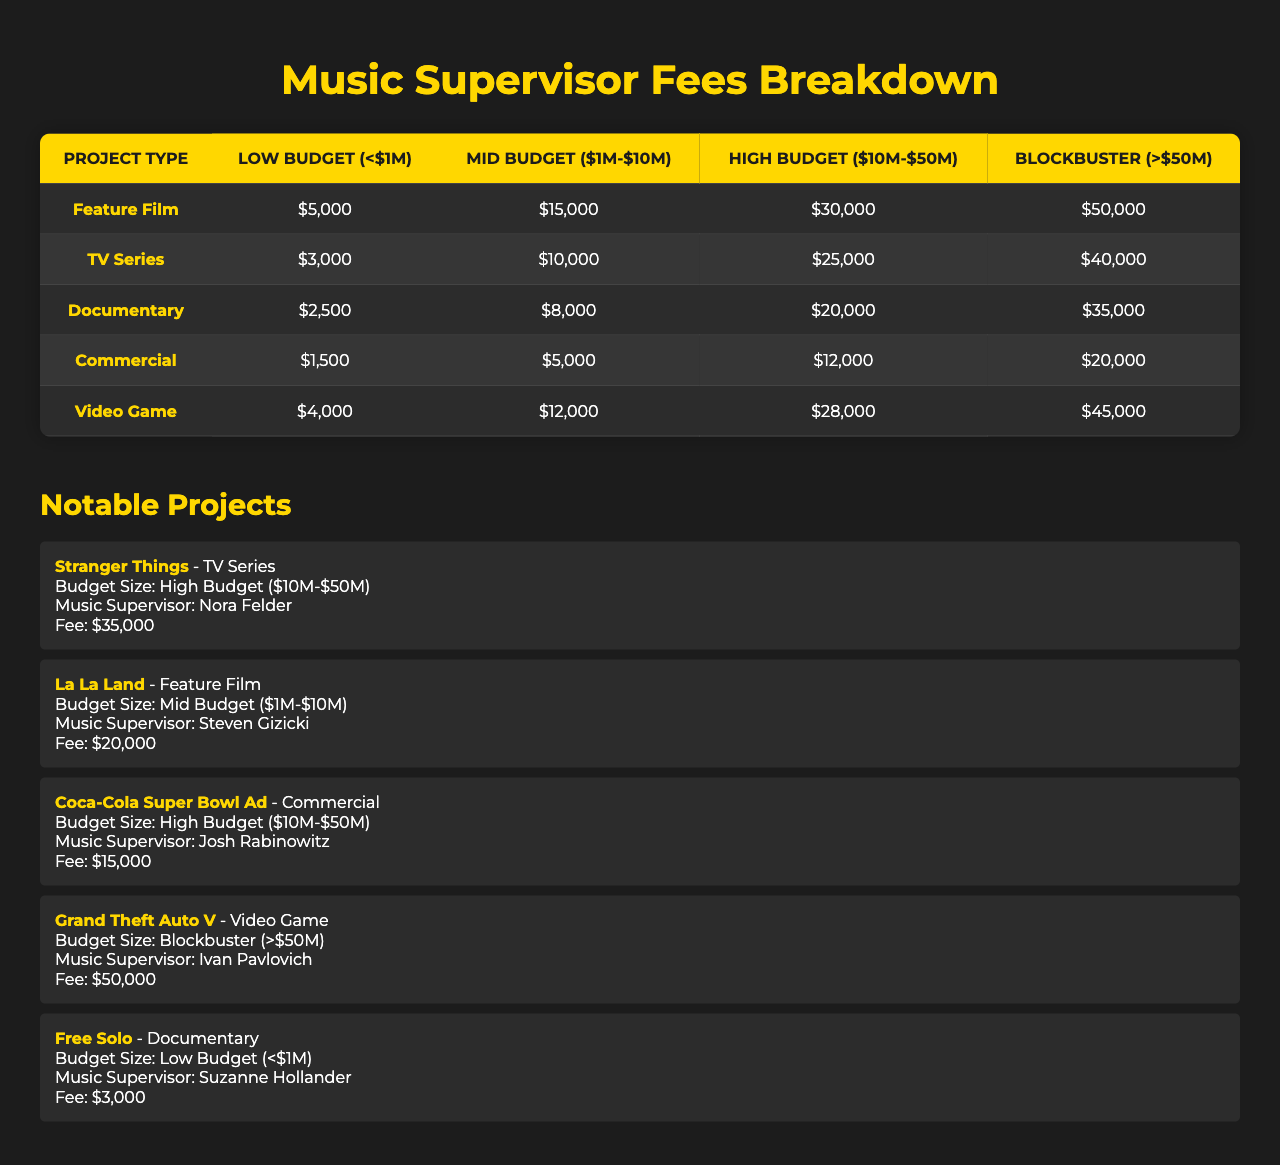What is the fee for a music supervisor on a low budget feature film? According to the table, the fee for a music supervisor on a low budget feature film is listed as $5,000.
Answer: $5,000 How much more does a music supervisor charge for a mid budget documentary compared to a low budget documentary? The mid budget documentary fee is $8,000 and the low budget documentary fee is $2,500. The difference is $8,000 - $2,500 = $5,500.
Answer: $5,500 What is the fee for a blockbuster video game? The table indicates that the fee for a blockbuster video game is $45,000.
Answer: $45,000 For a high budget commercial, what is the same fee charged for music supervision in a low budget feature film? The fee for a high budget commercial is $12,000, and the fee for a low budget feature film is $5,000. They are not the same.
Answer: No Which project type has the highest fee for low budget projects? The table shows that the highest fee for low budget projects is for a feature film at $5,000.
Answer: Feature Film If a TV series had a budget of $40 million, what would be the expected fee for a music supervisor? The table lists the fee for a high budget TV series (which includes $10M-$50M) as $25,000. Therefore, for a $40 million TV series, the expected fee is $25,000.
Answer: $25,000 What is the total fee for a music supervisor if a feature film and a commercial are both mid budget? The fee for a mid budget feature film is $15,000, and for a mid budget commercial, it is $5,000. The total fee is $15,000 + $5,000 = $20,000.
Answer: $20,000 Which music supervisor received the highest fee, and for what project? The table lists "Grand Theft Auto V" with a fee of $50,000, which is the highest fee paid to Ivan Pavlovich for music supervision.
Answer: Ivan Pavlovich for Grand Theft Auto V Is the fee for a high budget documentary less than the fee for a mid budget feature film? The fee for a high budget documentary is $20,000, while the fee for a mid budget feature film is $15,000. Therefore, the high budget documentary fee is greater than the mid budget feature film fee.
Answer: No What is the average fee for low budget projects across all project types? The low budget fees are $5,000 (Feature Film), $3,000 (TV Series), $2,500 (Documentary), $1,500 (Commercial), and $4,000 (Video Game). The sum is $5,000 + $3,000 + $2,500 + $1,500 + $4,000 = $16,000, and there are 5 project types. The average fee is $16,000/5 = $3,200.
Answer: $3,200 How does the music supervisor fee for a blockbuster film compare to that of a blockbuster video game? For a blockbuster film, the fee is $50,000 and for a blockbuster video game, it is $45,000. The difference is $50,000 - $45,000 = $5,000, indicating the film pays more.
Answer: $5,000 more for film 